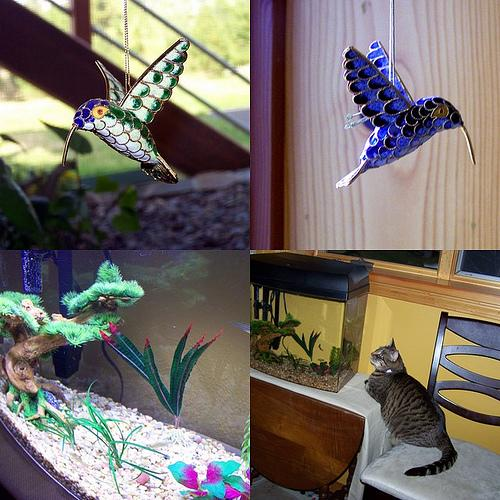What type of birds are in the top images?

Choices:
A) crows
B) doves
C) starlings
D) hummingbirds hummingbirds 